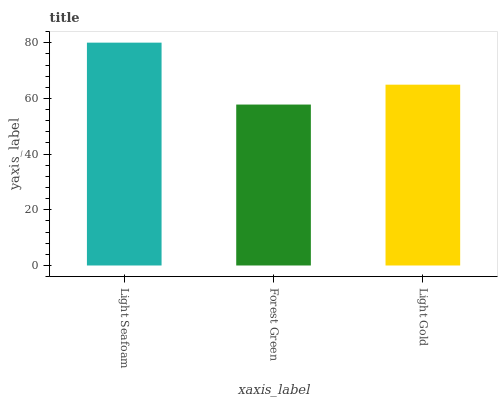Is Light Gold the minimum?
Answer yes or no. No. Is Light Gold the maximum?
Answer yes or no. No. Is Light Gold greater than Forest Green?
Answer yes or no. Yes. Is Forest Green less than Light Gold?
Answer yes or no. Yes. Is Forest Green greater than Light Gold?
Answer yes or no. No. Is Light Gold less than Forest Green?
Answer yes or no. No. Is Light Gold the high median?
Answer yes or no. Yes. Is Light Gold the low median?
Answer yes or no. Yes. Is Light Seafoam the high median?
Answer yes or no. No. Is Forest Green the low median?
Answer yes or no. No. 